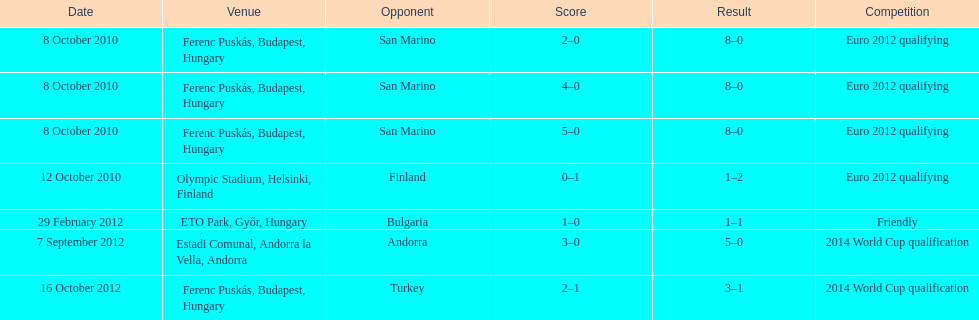How many goals were scored at the euro 2012 qualifying competition? 12. 